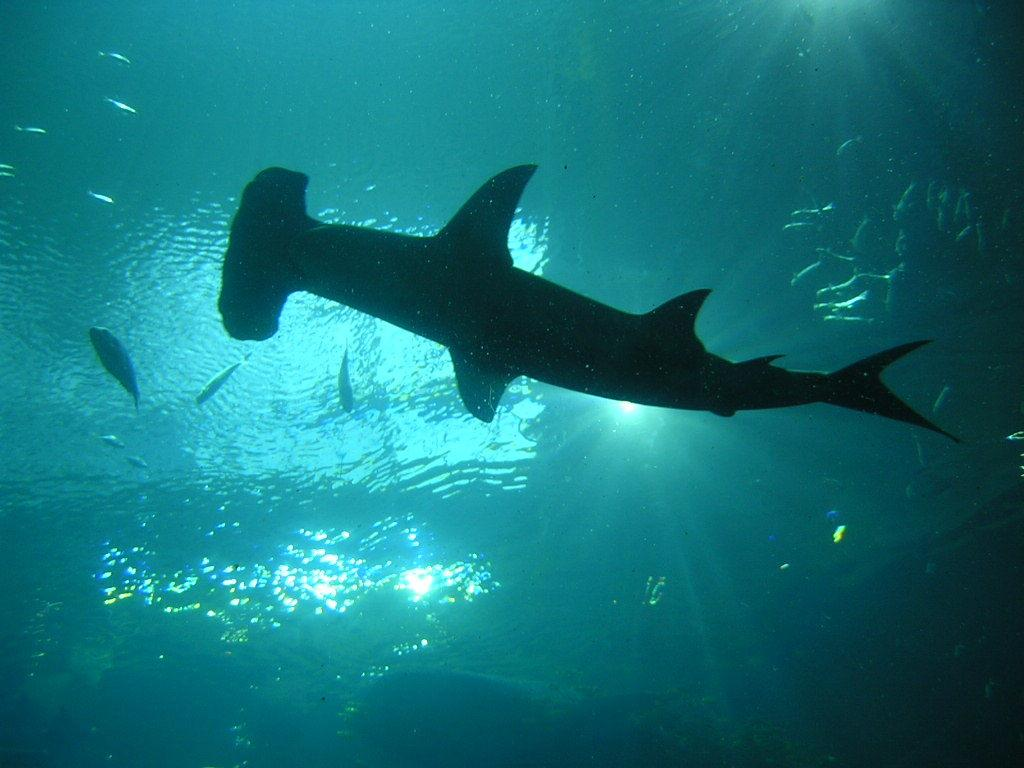What type of animals can be seen in the image? There are fishes in the water. Can you describe the location of the big fish in the image? There is a big fish in the middle of the image. What type of parcel is being delivered by the fish in the image? There is no parcel present in the image; it features fishes in the water. What type of pleasure can be seen on the fish's face in the image? There is no indication of the fish's emotions or facial expressions in the image. 